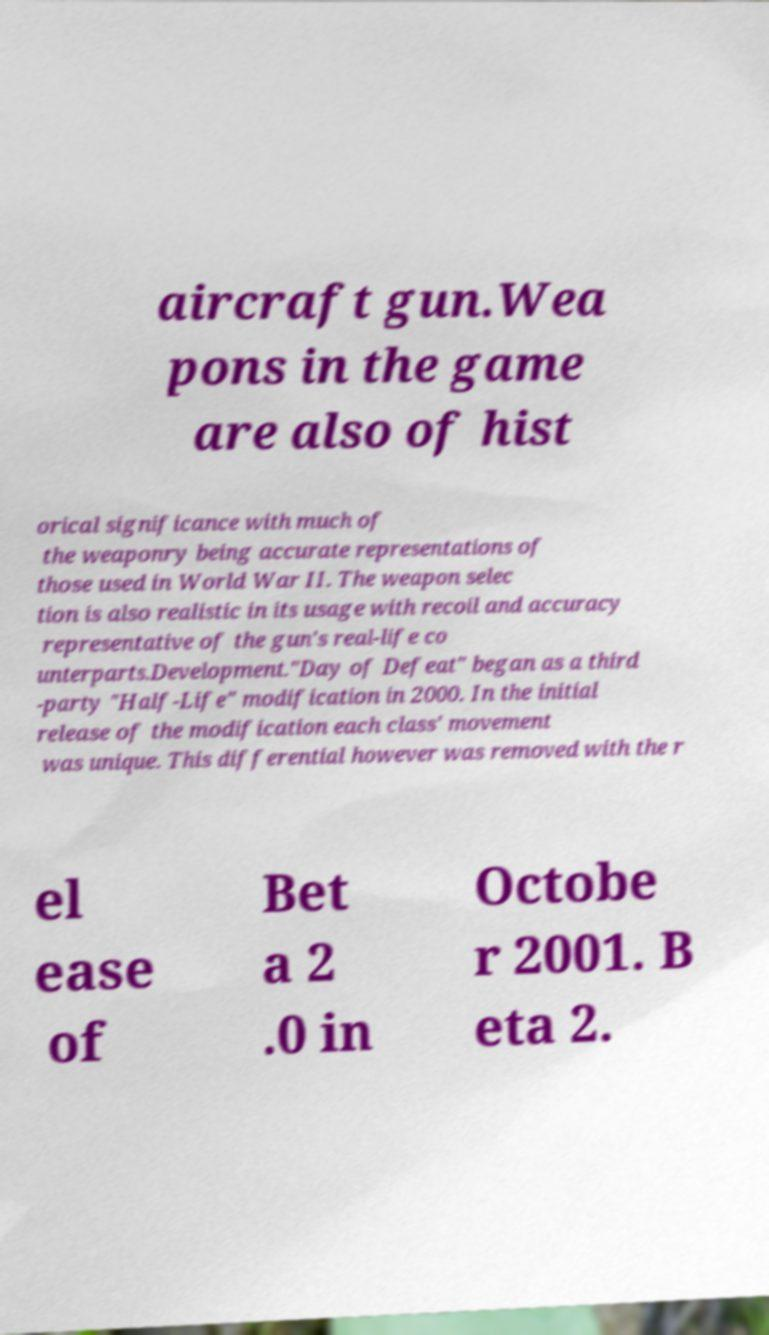For documentation purposes, I need the text within this image transcribed. Could you provide that? aircraft gun.Wea pons in the game are also of hist orical significance with much of the weaponry being accurate representations of those used in World War II. The weapon selec tion is also realistic in its usage with recoil and accuracy representative of the gun's real-life co unterparts.Development."Day of Defeat" began as a third -party "Half-Life" modification in 2000. In the initial release of the modification each class' movement was unique. This differential however was removed with the r el ease of Bet a 2 .0 in Octobe r 2001. B eta 2. 